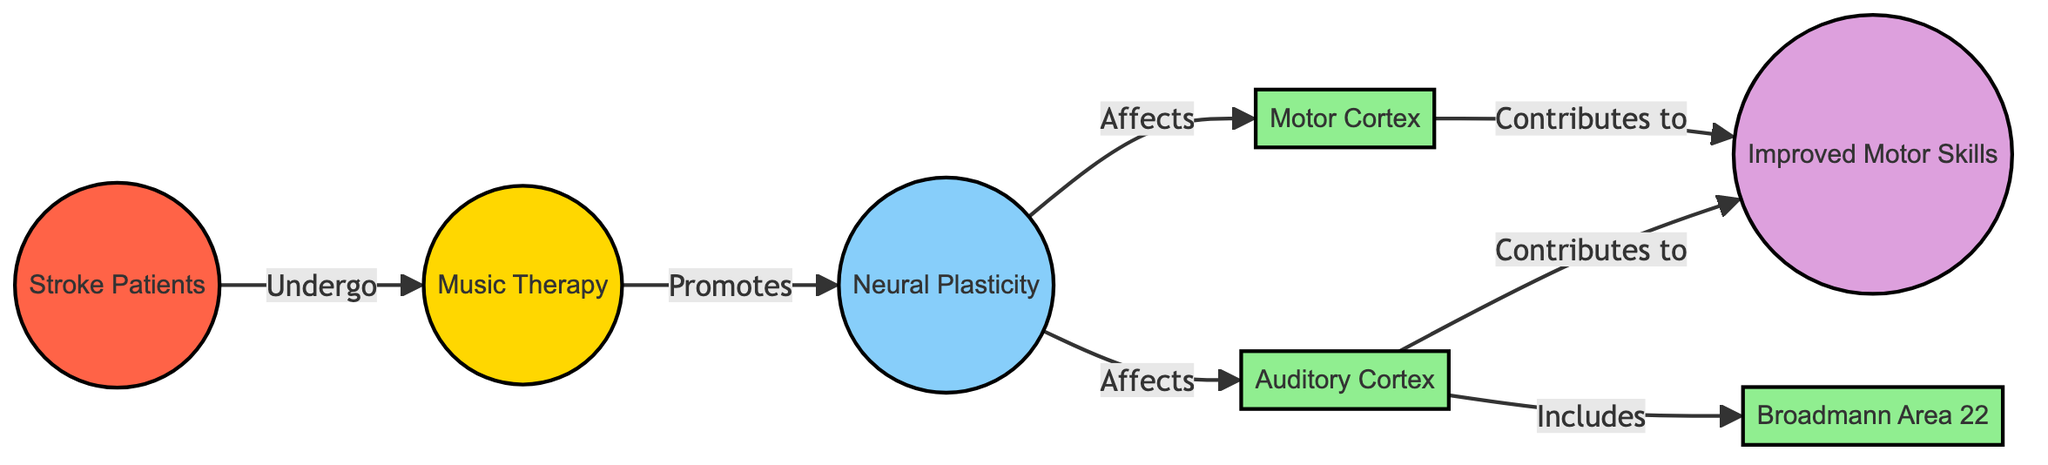What is the primary treatment shown in the diagram? The diagram identifies "Music Therapy" as the primary treatment, as indicated directly in the treatment node labeled "Music Therapy."
Answer: Music Therapy How many brain regions are depicted in the diagram? The diagram includes three distinct brain regions: Auditory Cortex, Motor Cortex, and Broadmann Area 22. Thus, counting these three nodes provides the total.
Answer: 3 What do stroke patients undergo according to the diagram? The diagram shows that stroke patients "Undergo" music therapy, as indicated by the directed edge linking stroke patients to music therapy.
Answer: Music therapy Which brain region is specifically mentioned to include Broadmann Area 22? According to the diagram, the "Auditory Cortex" is indicated as the brain region that includes Broadmann Area 22, shown by the link that indicates this relationship.
Answer: Auditory Cortex What outcome is a result of the impact on the auditory and motor cortices? The diagram indicates that both auditory cortex and motor cortex contribute to "Improved Motor Skills," which is the outcome of the neural plasticity promoted by music therapy.
Answer: Improved Motor Skills What effect does music therapy have on neural plasticity? The diagram specifically states that music therapy "Promotes" neural plasticity, showing a direct influence of the treatment on this process.
Answer: Promotes Which cortex contributes to improved motor skills in the diagram? Both auditory cortex and motor cortex are shown to contribute to improved motor skills as their output from neural plasticity affects this outcome.
Answer: Auditory Cortex, Motor Cortex What is the relationship between neural plasticity and motor cortex in the diagram? The diagram illustrates that neural plasticity "Affects" the motor cortex, establishing a direct relationship where neural plasticity influences this brain region.
Answer: Affects 